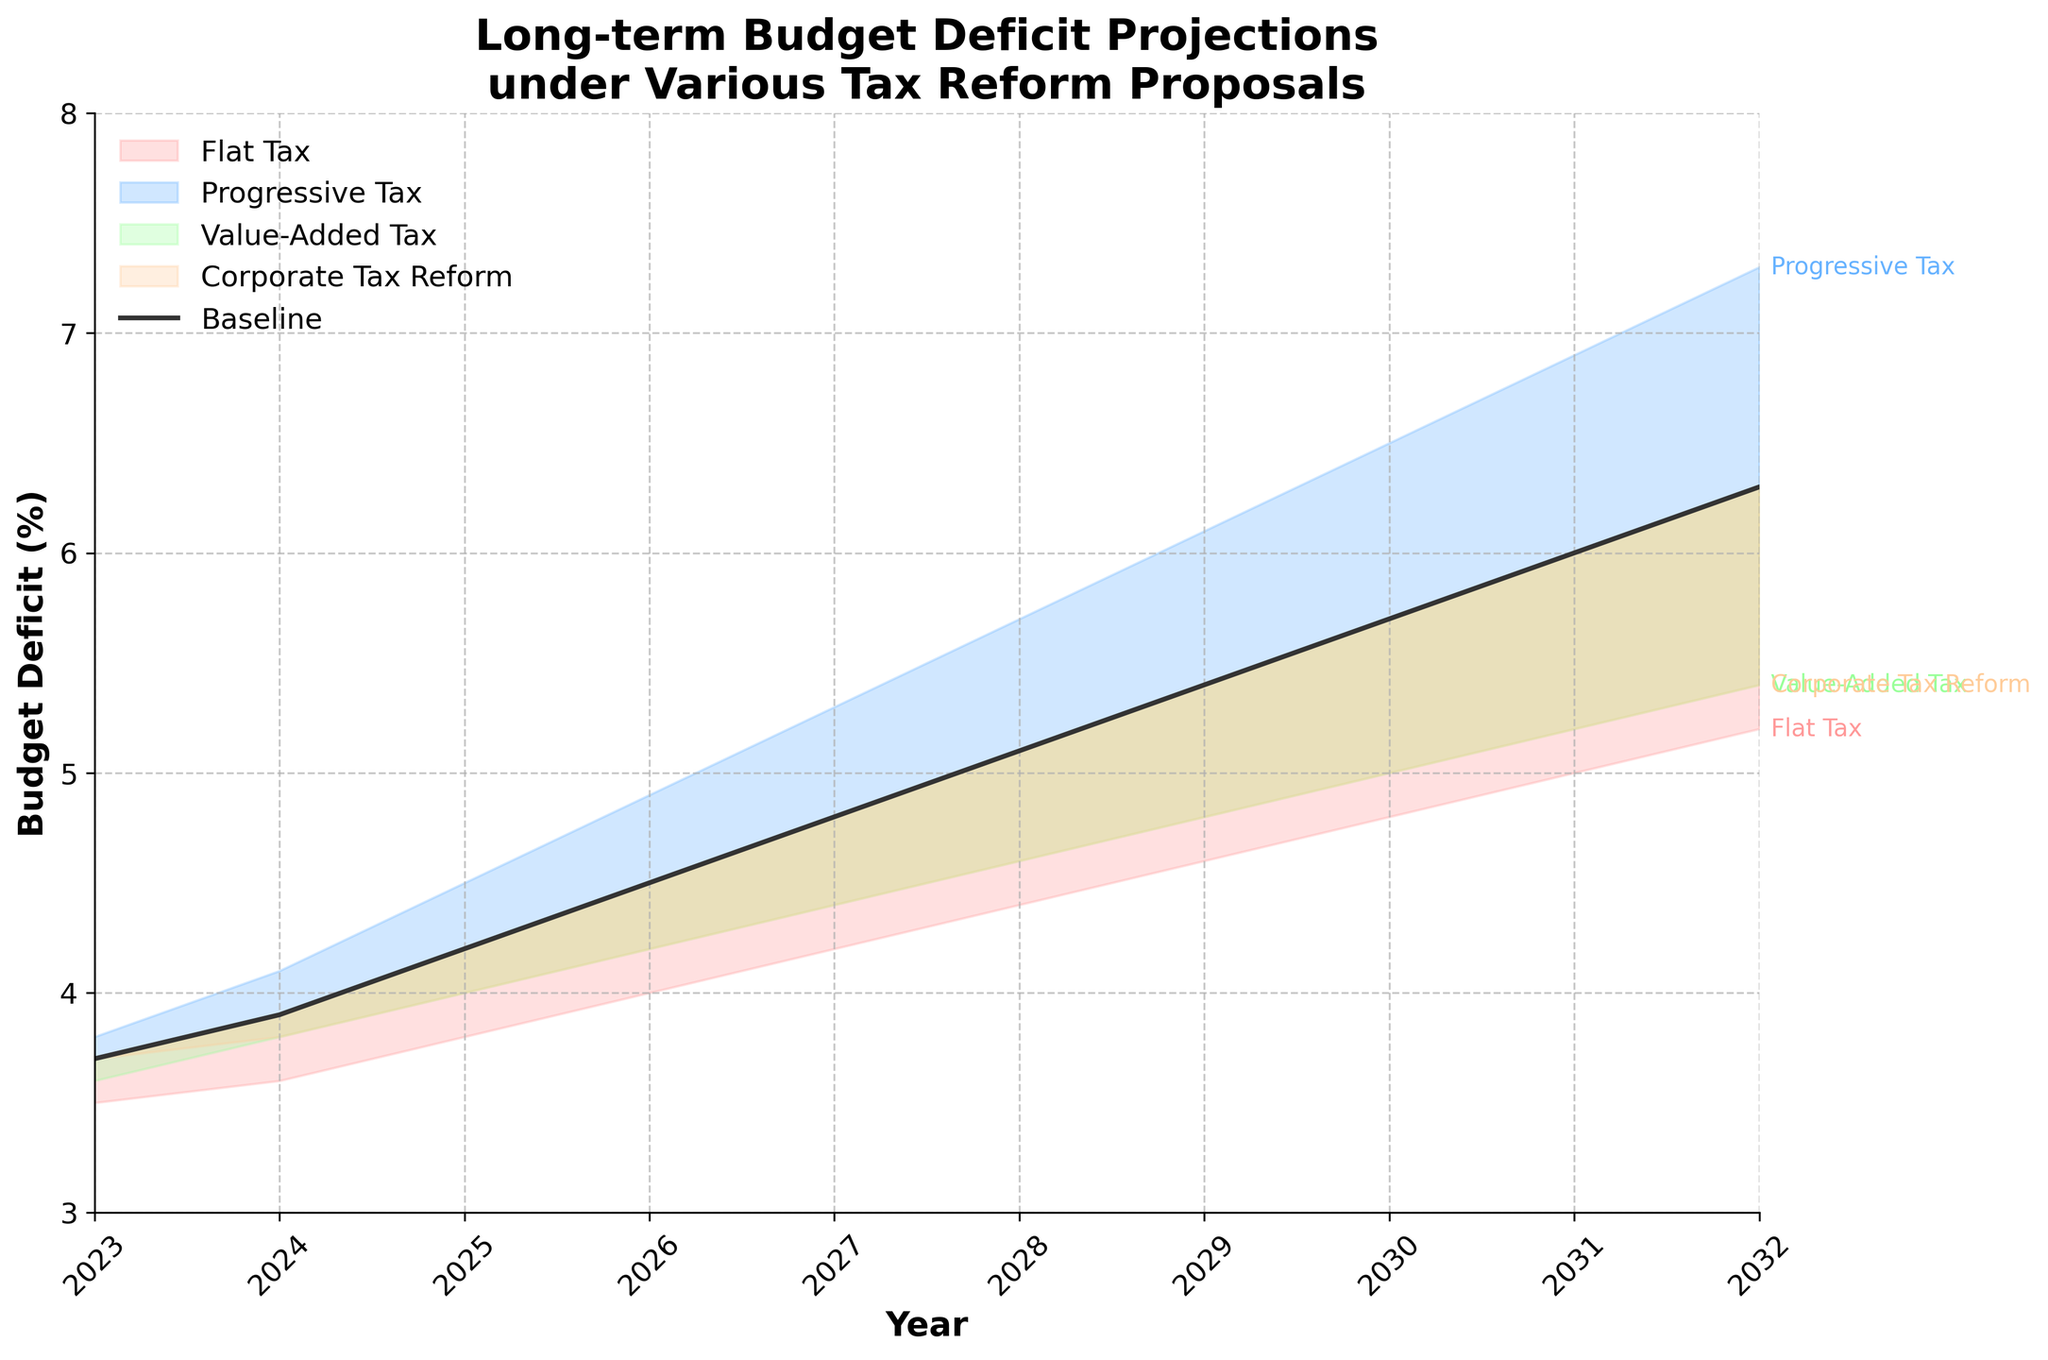What is the title of the chart? The title of the chart is displayed prominently at the top and provides an overview of the subject matter depicted.
Answer: Long-term Budget Deficit Projections under Various Tax Reform Proposals How many years are displayed on the x-axis? The x-axis shows a range of years, each marked with a tick. Counting these ticks gives the total number of years displayed.
Answer: 10 Which tax reform proposal shows the highest budget deficit projection for the year 2032? To find this, look at the different lines at the year 2032 and identify the line that reaches the highest point on the y-axis.
Answer: Progressive Tax What color represents the Value-Added Tax proposal? By examining the legend or the colored region that corresponds to the Value-Added Tax, its color can be identified.
Answer: Orange Between which two years does the baseline projection first exceed 5%? Locate the baseline line and identify where it crosses the 5% mark on the y-axis, and check the corresponding years on the x-axis.
Answer: 2028 and 2029 Which tax proposal results in the lowest budget deficit projection throughout the entire period? Compare all the colored regions and identify the one consistently below all others across all years.
Answer: Flat Tax What is the difference in budget deficit projection between the baseline and the Value-Added Tax proposal in the year 2027? Find the y-values at 2027 for both the baseline and the Value-Added Tax, then subtract the baseline value from the Value-Added Tax value.
Answer: 4.4 - 4.8 = -0.4% What is the trend in the budget deficit projection for the Corporate Tax Reform from 2023 to 2032? Examine the line representing Corporate Tax Reform from start to end and describe the general pattern it follows.
Answer: Increasing In which year does the Progressive Tax proposal show a budget deficit of approximately 5%? Follow the Progressive Tax line and identify the year where it crosses the 5% mark on the y-axis.
Answer: 2027 How does the baseline projection compare to the budget deficit under the Value-Added Tax proposal in 2030? Look at the values for both the baseline and the Value-Added Tax proposal at the year 2030 to determine the relationship.
Answer: The baseline projection is lower than the Value-Added Tax proposal 